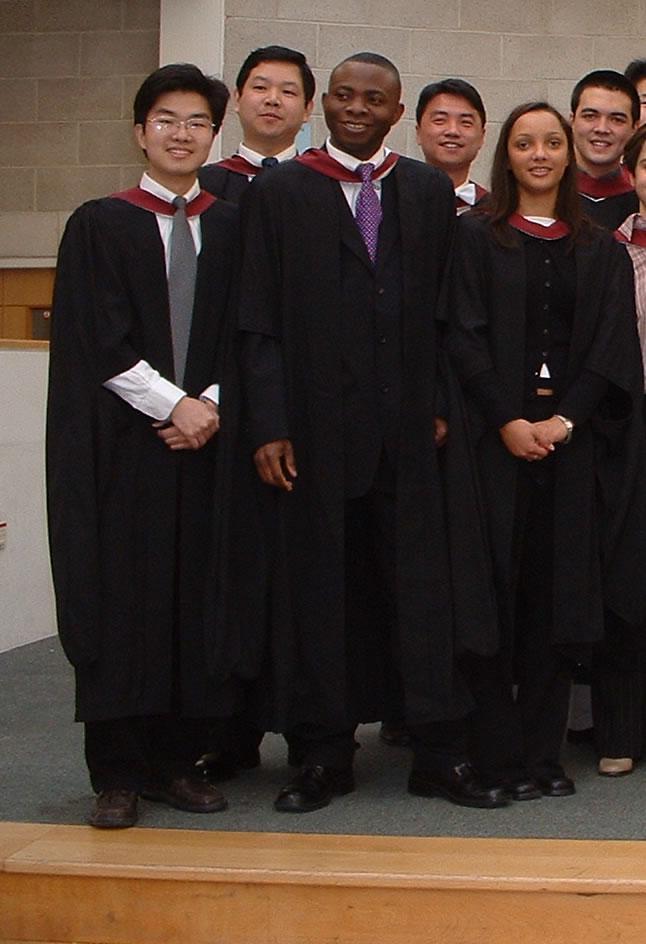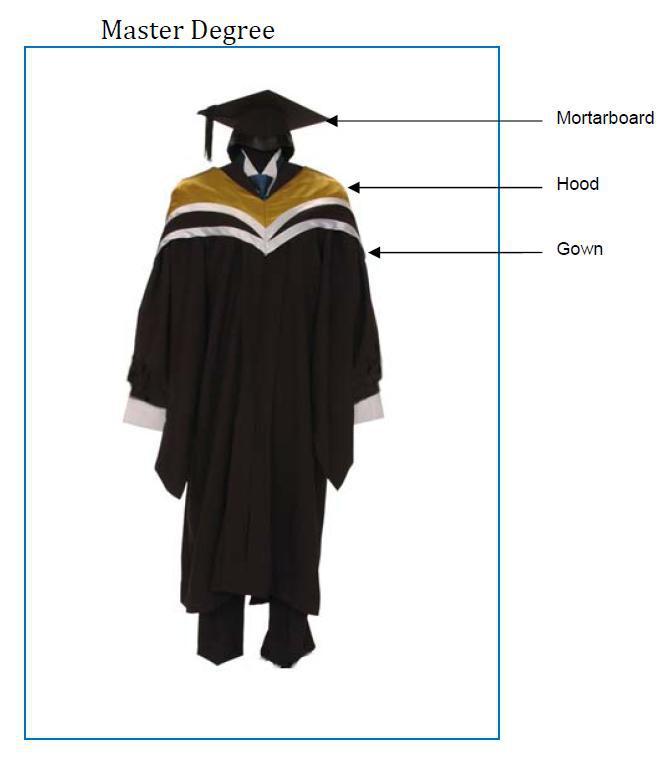The first image is the image on the left, the second image is the image on the right. For the images shown, is this caption "One photo has at least one male wearing a purple tie that is visible." true? Answer yes or no. Yes. The first image is the image on the left, the second image is the image on the right. Given the left and right images, does the statement "The left image contains at least 4 students in gowns, and you can see their entire body, head to foot." hold true? Answer yes or no. Yes. 